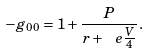Convert formula to latex. <formula><loc_0><loc_0><loc_500><loc_500>- g _ { 0 0 } = 1 + \frac { P } { r + \ e \frac { V } { 4 } } .</formula> 